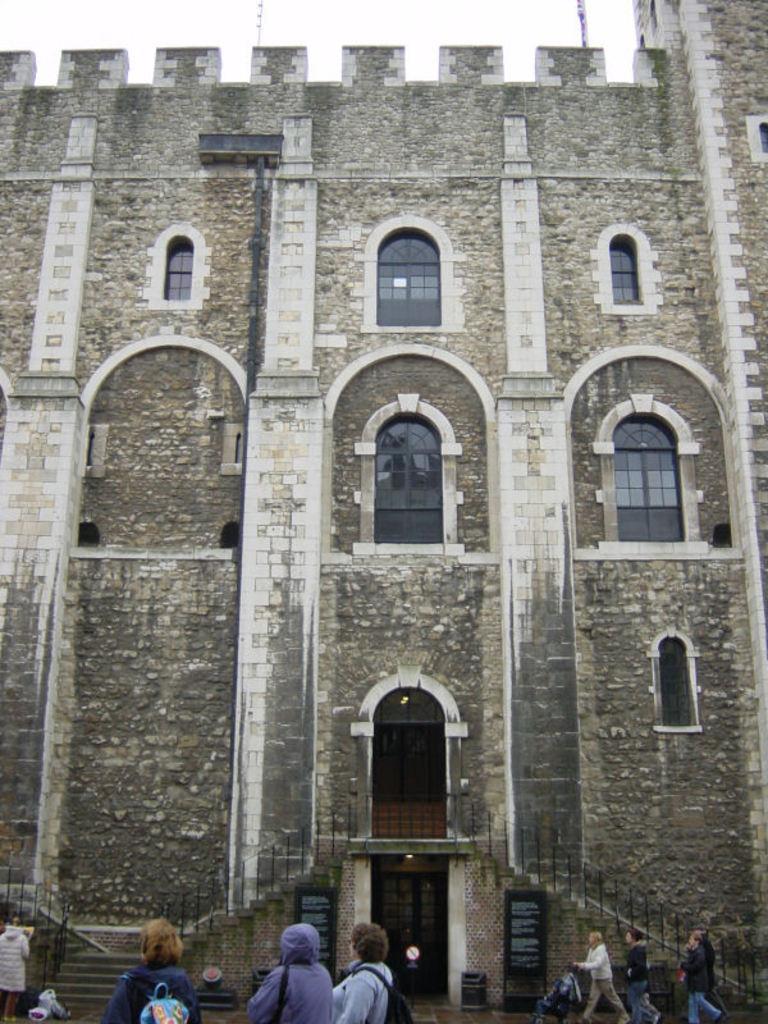Can you describe this image briefly? At the bottom of the picture, we see three people are standing. In the right bottom, we see three people are walking. In front of them, we see a baby trolley. In the left bottom, we see a woman is standing and beside her, we see the staircase and the stair railing. In the middle, we see a building which is made up of stones. It has windows and a door. We even see a black gate. Beside that, we see a garbage bin and a board in black color with some text written on it. At the top, we see the sky. 